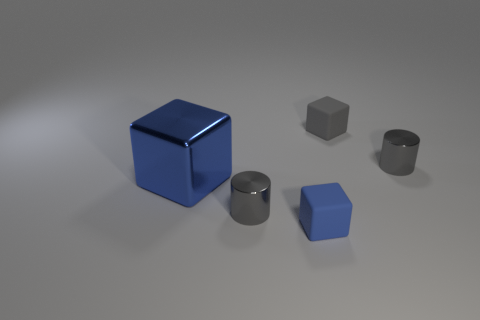Add 3 matte objects. How many objects exist? 8 Subtract all blocks. How many objects are left? 2 Add 4 gray rubber blocks. How many gray rubber blocks are left? 5 Add 5 tiny brown rubber spheres. How many tiny brown rubber spheres exist? 5 Subtract 0 cyan cylinders. How many objects are left? 5 Subtract all shiny objects. Subtract all big gray cylinders. How many objects are left? 2 